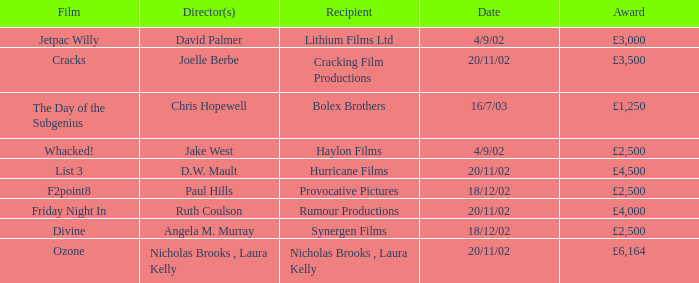Who won an award of £3,000 on 4/9/02? Lithium Films Ltd. 